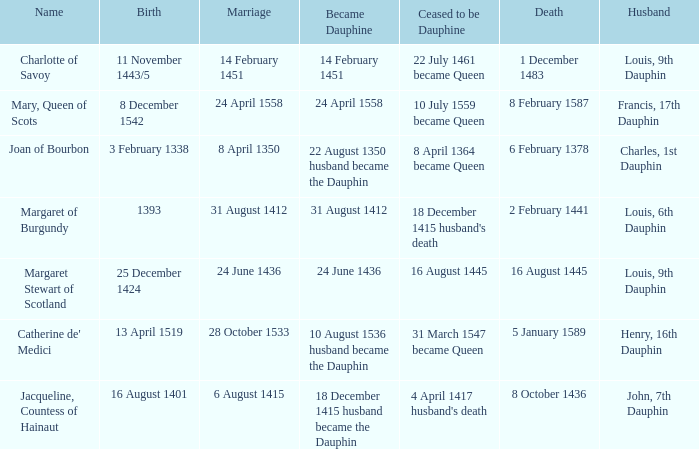Parse the table in full. {'header': ['Name', 'Birth', 'Marriage', 'Became Dauphine', 'Ceased to be Dauphine', 'Death', 'Husband'], 'rows': [['Charlotte of Savoy', '11 November 1443/5', '14 February 1451', '14 February 1451', '22 July 1461 became Queen', '1 December 1483', 'Louis, 9th Dauphin'], ['Mary, Queen of Scots', '8 December 1542', '24 April 1558', '24 April 1558', '10 July 1559 became Queen', '8 February 1587', 'Francis, 17th Dauphin'], ['Joan of Bourbon', '3 February 1338', '8 April 1350', '22 August 1350 husband became the Dauphin', '8 April 1364 became Queen', '6 February 1378', 'Charles, 1st Dauphin'], ['Margaret of Burgundy', '1393', '31 August 1412', '31 August 1412', "18 December 1415 husband's death", '2 February 1441', 'Louis, 6th Dauphin'], ['Margaret Stewart of Scotland', '25 December 1424', '24 June 1436', '24 June 1436', '16 August 1445', '16 August 1445', 'Louis, 9th Dauphin'], ["Catherine de' Medici", '13 April 1519', '28 October 1533', '10 August 1536 husband became the Dauphin', '31 March 1547 became Queen', '5 January 1589', 'Henry, 16th Dauphin'], ['Jacqueline, Countess of Hainaut', '16 August 1401', '6 August 1415', '18 December 1415 husband became the Dauphin', "4 April 1417 husband's death", '8 October 1436', 'John, 7th Dauphin']]} When was the marriage when became dauphine is 31 august 1412? 31 August 1412. 